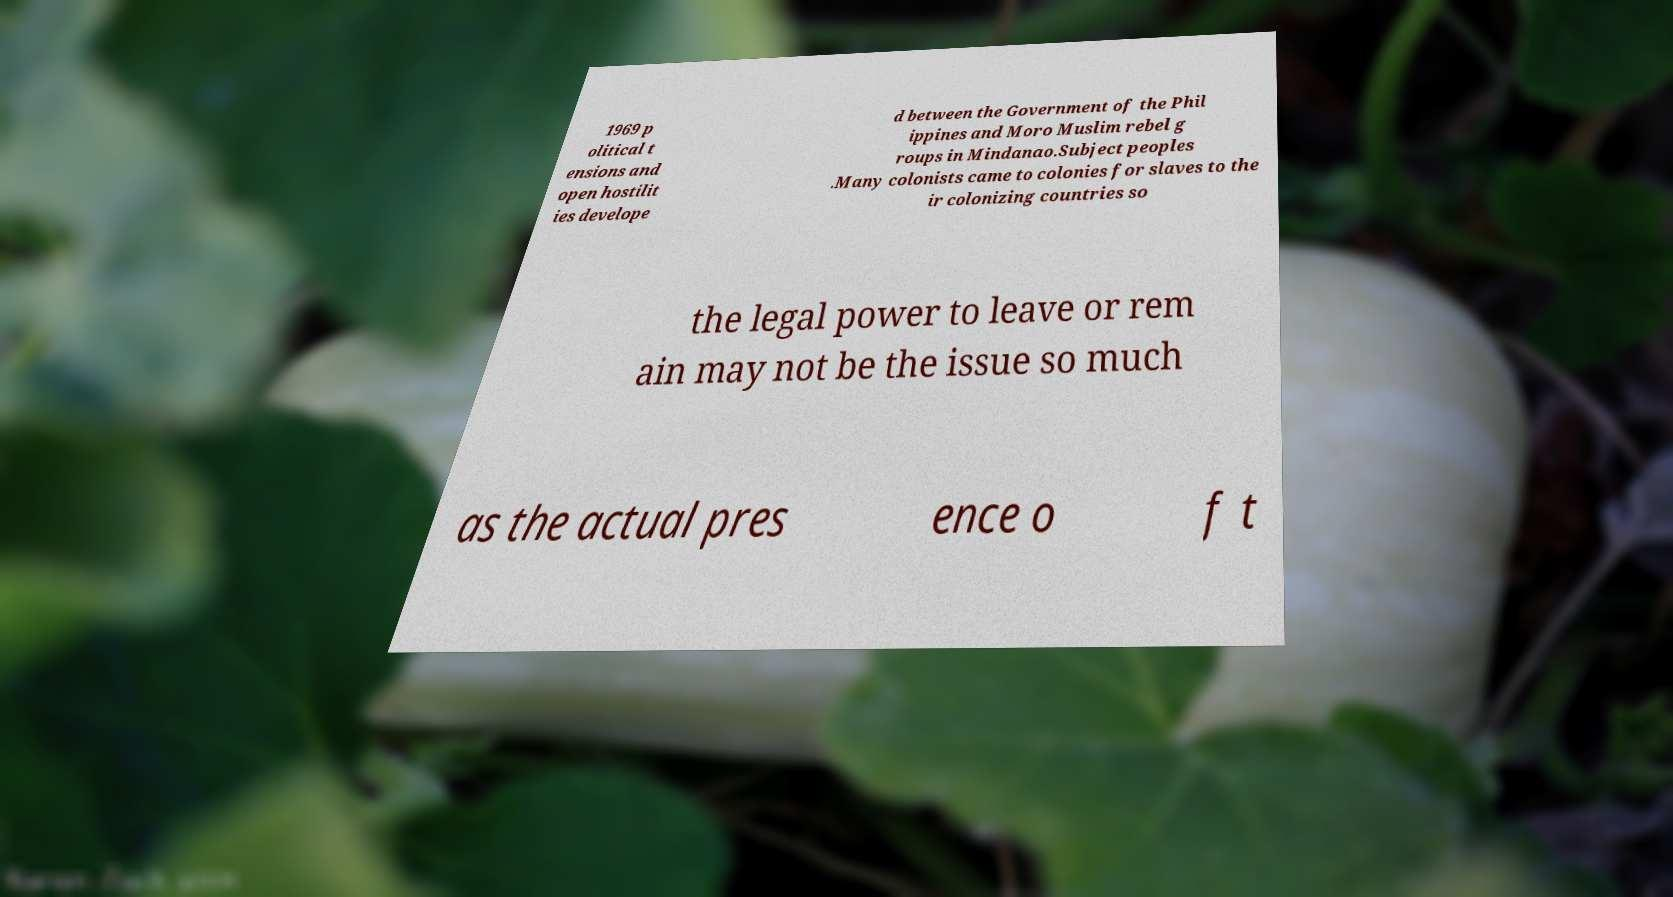For documentation purposes, I need the text within this image transcribed. Could you provide that? 1969 p olitical t ensions and open hostilit ies develope d between the Government of the Phil ippines and Moro Muslim rebel g roups in Mindanao.Subject peoples .Many colonists came to colonies for slaves to the ir colonizing countries so the legal power to leave or rem ain may not be the issue so much as the actual pres ence o f t 